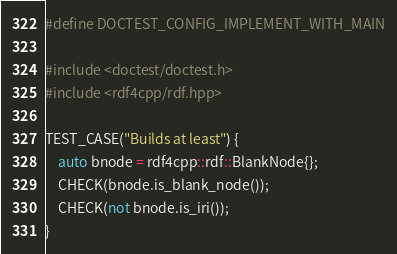Convert code to text. <code><loc_0><loc_0><loc_500><loc_500><_C++_>
#define DOCTEST_CONFIG_IMPLEMENT_WITH_MAIN

#include <doctest/doctest.h>
#include <rdf4cpp/rdf.hpp>

TEST_CASE("Builds at least") {
    auto bnode = rdf4cpp::rdf::BlankNode{};
    CHECK(bnode.is_blank_node());
    CHECK(not bnode.is_iri());
}</code> 